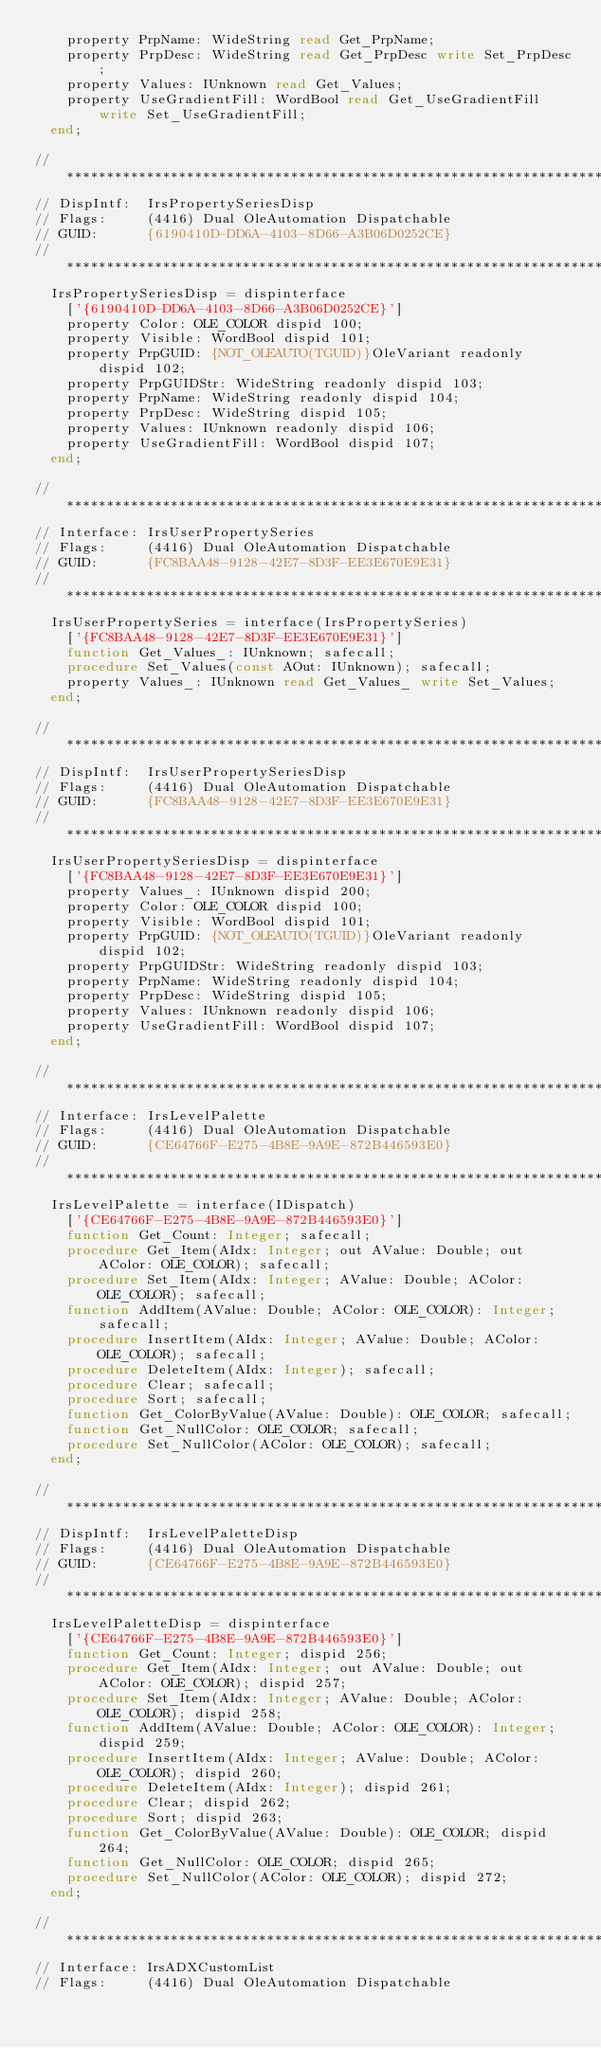<code> <loc_0><loc_0><loc_500><loc_500><_Pascal_>    property PrpName: WideString read Get_PrpName;
    property PrpDesc: WideString read Get_PrpDesc write Set_PrpDesc;
    property Values: IUnknown read Get_Values;
    property UseGradientFill: WordBool read Get_UseGradientFill write Set_UseGradientFill;
  end;

// *********************************************************************//
// DispIntf:  IrsPropertySeriesDisp
// Flags:     (4416) Dual OleAutomation Dispatchable
// GUID:      {6190410D-DD6A-4103-8D66-A3B06D0252CE}
// *********************************************************************//
  IrsPropertySeriesDisp = dispinterface
    ['{6190410D-DD6A-4103-8D66-A3B06D0252CE}']
    property Color: OLE_COLOR dispid 100;
    property Visible: WordBool dispid 101;
    property PrpGUID: {NOT_OLEAUTO(TGUID)}OleVariant readonly dispid 102;
    property PrpGUIDStr: WideString readonly dispid 103;
    property PrpName: WideString readonly dispid 104;
    property PrpDesc: WideString dispid 105;
    property Values: IUnknown readonly dispid 106;
    property UseGradientFill: WordBool dispid 107;
  end;

// *********************************************************************//
// Interface: IrsUserPropertySeries
// Flags:     (4416) Dual OleAutomation Dispatchable
// GUID:      {FC8BAA48-9128-42E7-8D3F-EE3E670E9E31}
// *********************************************************************//
  IrsUserPropertySeries = interface(IrsPropertySeries)
    ['{FC8BAA48-9128-42E7-8D3F-EE3E670E9E31}']
    function Get_Values_: IUnknown; safecall;
    procedure Set_Values(const AOut: IUnknown); safecall;
    property Values_: IUnknown read Get_Values_ write Set_Values;
  end;

// *********************************************************************//
// DispIntf:  IrsUserPropertySeriesDisp
// Flags:     (4416) Dual OleAutomation Dispatchable
// GUID:      {FC8BAA48-9128-42E7-8D3F-EE3E670E9E31}
// *********************************************************************//
  IrsUserPropertySeriesDisp = dispinterface
    ['{FC8BAA48-9128-42E7-8D3F-EE3E670E9E31}']
    property Values_: IUnknown dispid 200;
    property Color: OLE_COLOR dispid 100;
    property Visible: WordBool dispid 101;
    property PrpGUID: {NOT_OLEAUTO(TGUID)}OleVariant readonly dispid 102;
    property PrpGUIDStr: WideString readonly dispid 103;
    property PrpName: WideString readonly dispid 104;
    property PrpDesc: WideString dispid 105;
    property Values: IUnknown readonly dispid 106;
    property UseGradientFill: WordBool dispid 107;
  end;

// *********************************************************************//
// Interface: IrsLevelPalette
// Flags:     (4416) Dual OleAutomation Dispatchable
// GUID:      {CE64766F-E275-4B8E-9A9E-872B446593E0}
// *********************************************************************//
  IrsLevelPalette = interface(IDispatch)
    ['{CE64766F-E275-4B8E-9A9E-872B446593E0}']
    function Get_Count: Integer; safecall;
    procedure Get_Item(AIdx: Integer; out AValue: Double; out AColor: OLE_COLOR); safecall;
    procedure Set_Item(AIdx: Integer; AValue: Double; AColor: OLE_COLOR); safecall;
    function AddItem(AValue: Double; AColor: OLE_COLOR): Integer; safecall;
    procedure InsertItem(AIdx: Integer; AValue: Double; AColor: OLE_COLOR); safecall;
    procedure DeleteItem(AIdx: Integer); safecall;
    procedure Clear; safecall;
    procedure Sort; safecall;
    function Get_ColorByValue(AValue: Double): OLE_COLOR; safecall;
    function Get_NullColor: OLE_COLOR; safecall;
    procedure Set_NullColor(AColor: OLE_COLOR); safecall;
  end;

// *********************************************************************//
// DispIntf:  IrsLevelPaletteDisp
// Flags:     (4416) Dual OleAutomation Dispatchable
// GUID:      {CE64766F-E275-4B8E-9A9E-872B446593E0}
// *********************************************************************//
  IrsLevelPaletteDisp = dispinterface
    ['{CE64766F-E275-4B8E-9A9E-872B446593E0}']
    function Get_Count: Integer; dispid 256;
    procedure Get_Item(AIdx: Integer; out AValue: Double; out AColor: OLE_COLOR); dispid 257;
    procedure Set_Item(AIdx: Integer; AValue: Double; AColor: OLE_COLOR); dispid 258;
    function AddItem(AValue: Double; AColor: OLE_COLOR): Integer; dispid 259;
    procedure InsertItem(AIdx: Integer; AValue: Double; AColor: OLE_COLOR); dispid 260;
    procedure DeleteItem(AIdx: Integer); dispid 261;
    procedure Clear; dispid 262;
    procedure Sort; dispid 263;
    function Get_ColorByValue(AValue: Double): OLE_COLOR; dispid 264;
    function Get_NullColor: OLE_COLOR; dispid 265;
    procedure Set_NullColor(AColor: OLE_COLOR); dispid 272;
  end;

// *********************************************************************//
// Interface: IrsADXCustomList
// Flags:     (4416) Dual OleAutomation Dispatchable</code> 